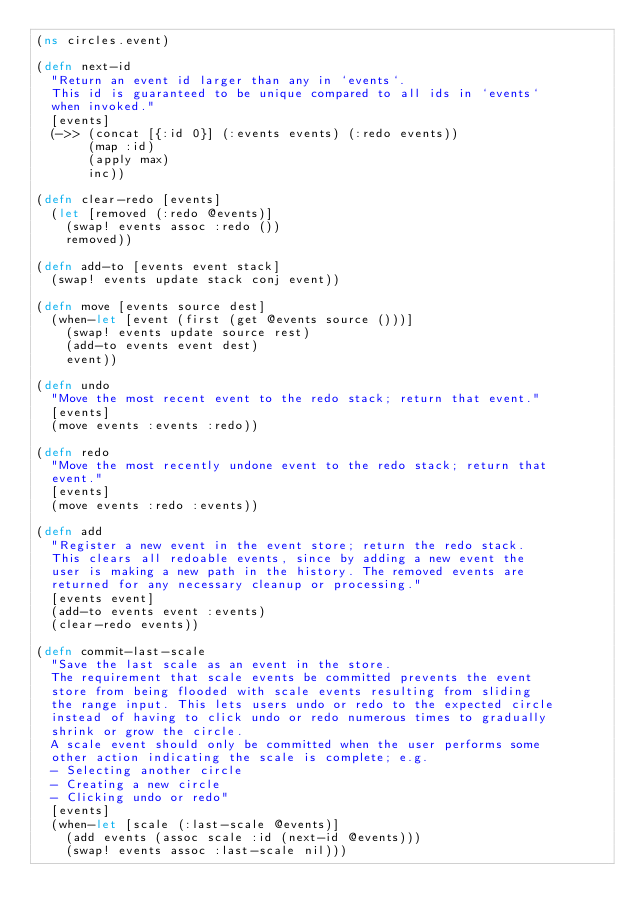<code> <loc_0><loc_0><loc_500><loc_500><_Clojure_>(ns circles.event)

(defn next-id
  "Return an event id larger than any in `events`.
  This id is guaranteed to be unique compared to all ids in `events`
  when invoked."
  [events]
  (->> (concat [{:id 0}] (:events events) (:redo events))
       (map :id)
       (apply max)
       inc))

(defn clear-redo [events]
  (let [removed (:redo @events)]
    (swap! events assoc :redo ())
    removed))

(defn add-to [events event stack]
  (swap! events update stack conj event))

(defn move [events source dest]
  (when-let [event (first (get @events source ()))]
    (swap! events update source rest)
    (add-to events event dest)
    event))

(defn undo
  "Move the most recent event to the redo stack; return that event."
  [events]
  (move events :events :redo))

(defn redo
  "Move the most recently undone event to the redo stack; return that
  event."
  [events]
  (move events :redo :events))

(defn add
  "Register a new event in the event store; return the redo stack.
  This clears all redoable events, since by adding a new event the
  user is making a new path in the history. The removed events are
  returned for any necessary cleanup or processing."
  [events event]
  (add-to events event :events)
  (clear-redo events))

(defn commit-last-scale
  "Save the last scale as an event in the store.
  The requirement that scale events be committed prevents the event
  store from being flooded with scale events resulting from sliding
  the range input. This lets users undo or redo to the expected circle
  instead of having to click undo or redo numerous times to gradually
  shrink or grow the circle.
  A scale event should only be committed when the user performs some
  other action indicating the scale is complete; e.g.
  - Selecting another circle
  - Creating a new circle
  - Clicking undo or redo"
  [events]
  (when-let [scale (:last-scale @events)]
    (add events (assoc scale :id (next-id @events)))
    (swap! events assoc :last-scale nil)))
</code> 